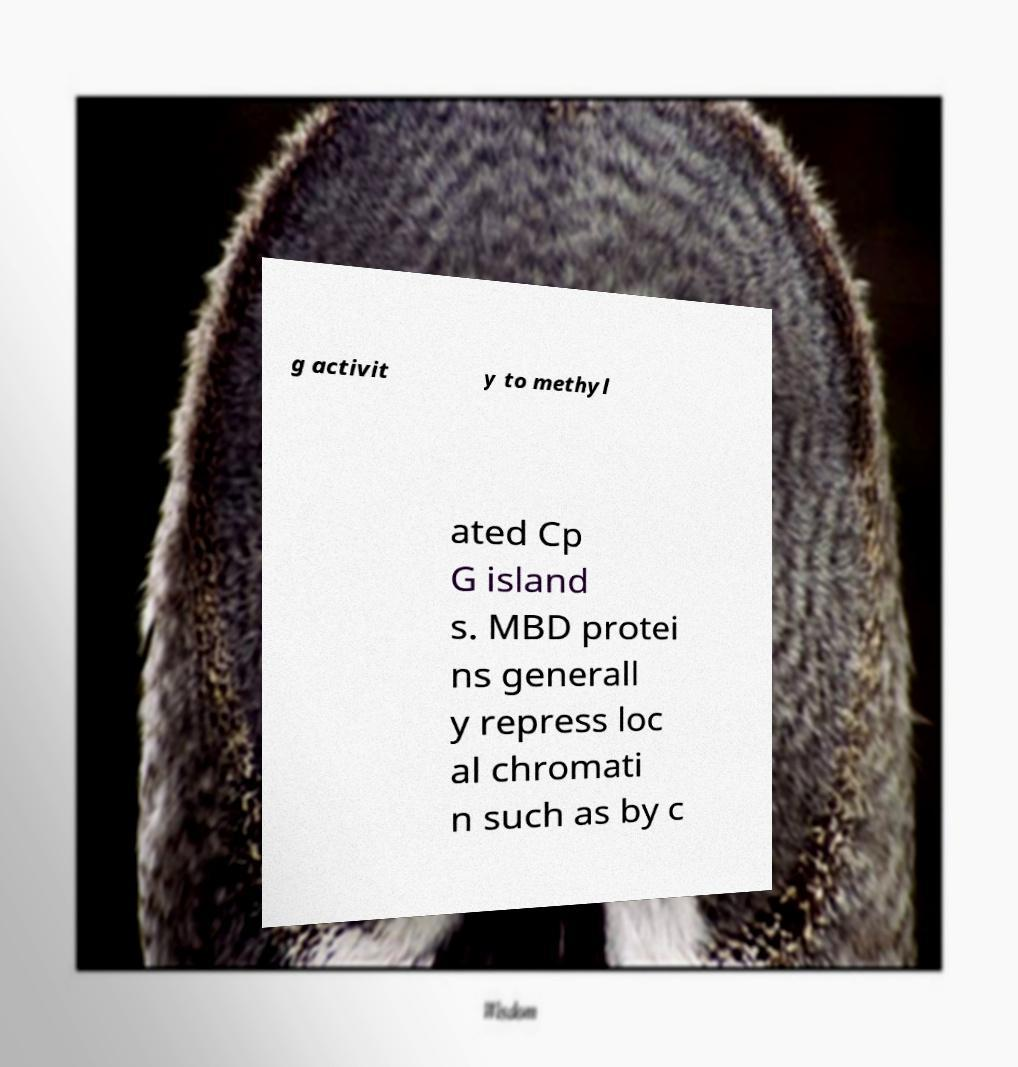Could you assist in decoding the text presented in this image and type it out clearly? g activit y to methyl ated Cp G island s. MBD protei ns generall y repress loc al chromati n such as by c 